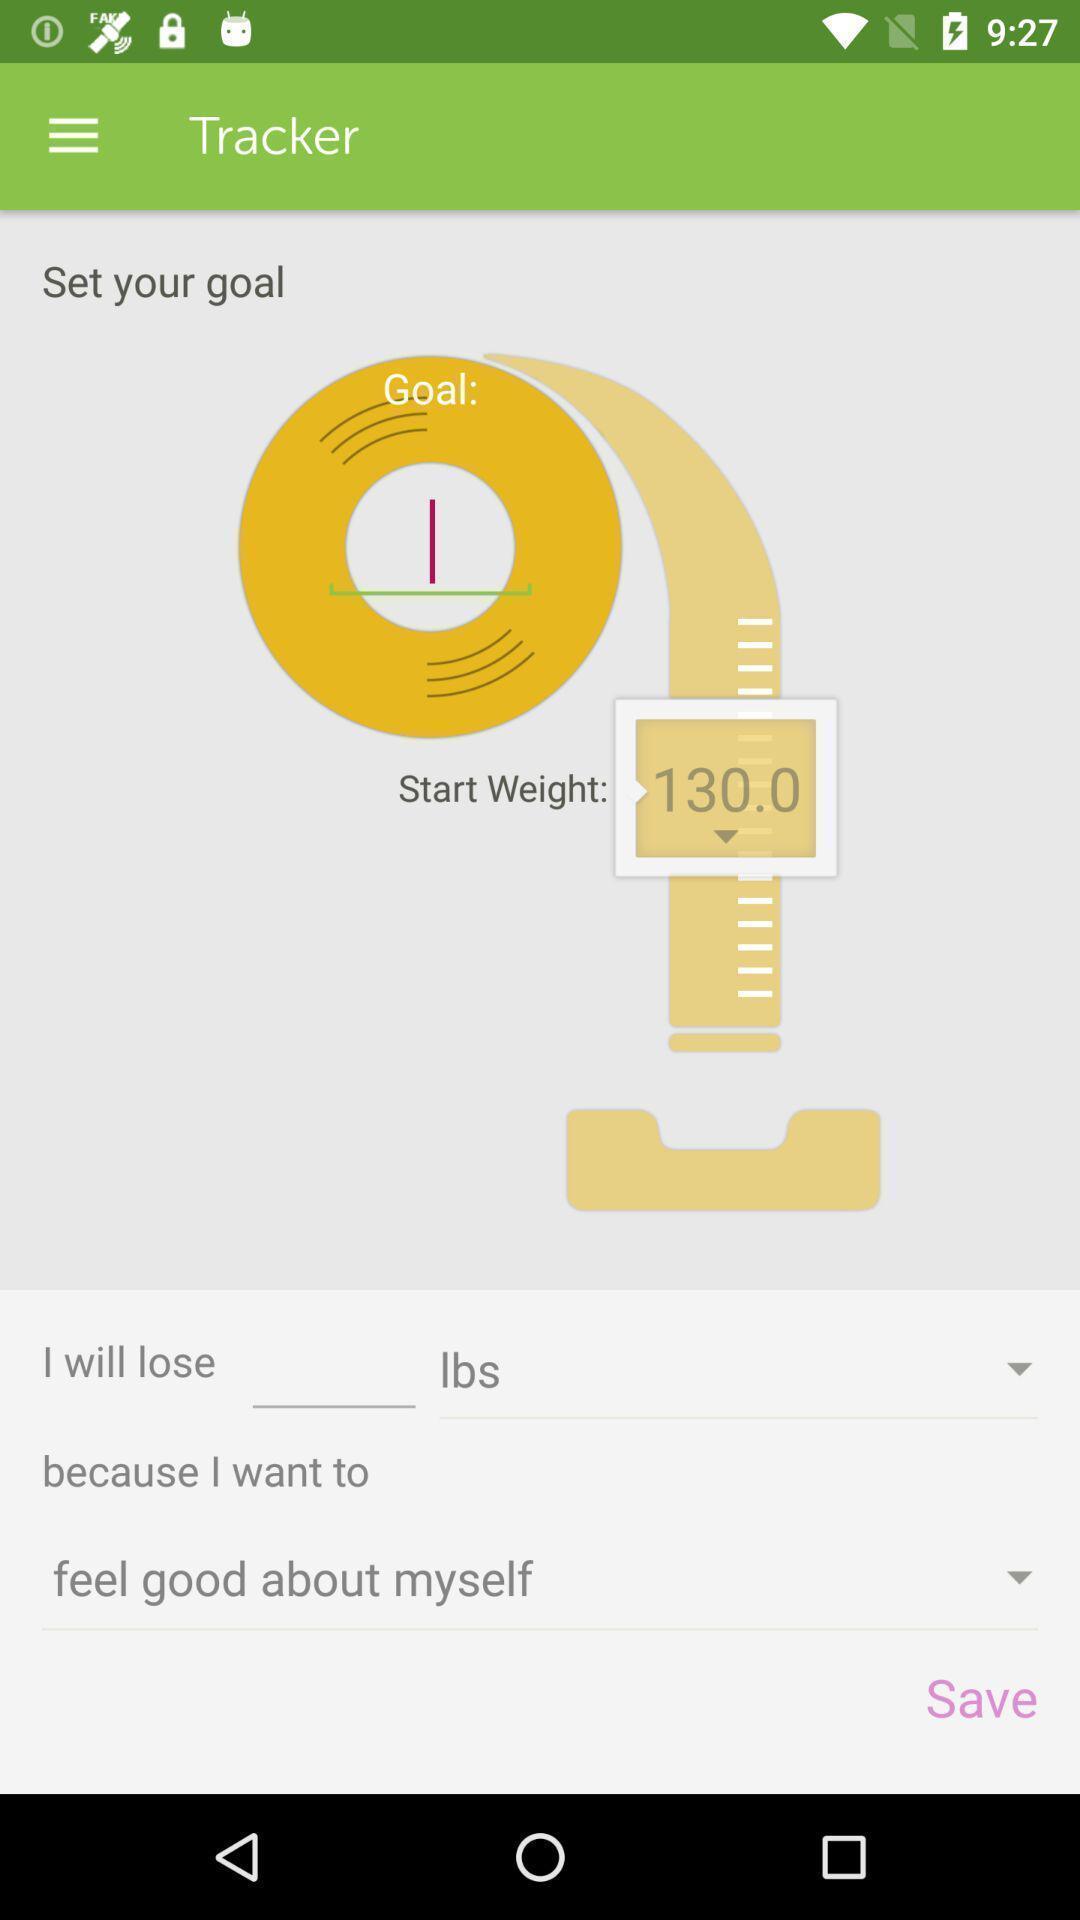Explain the elements present in this screenshot. Page showing tracker on fitness app. 